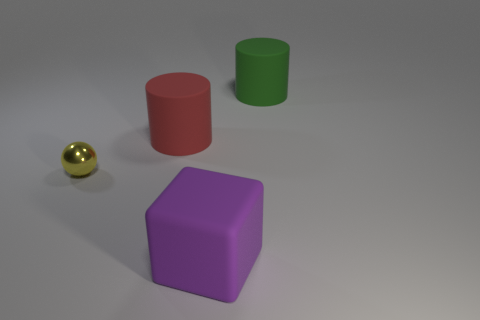Do the red object and the big green thing have the same shape?
Offer a terse response. Yes. What size is the green matte thing that is the same shape as the red rubber thing?
Your response must be concise. Large. Does the thing in front of the metal thing have the same size as the green object?
Offer a terse response. Yes. What size is the object that is both on the left side of the purple rubber cube and behind the small yellow sphere?
Offer a terse response. Large. What number of small objects have the same color as the small sphere?
Provide a short and direct response. 0. Are there an equal number of green things that are left of the purple object and yellow rubber objects?
Offer a terse response. Yes. The tiny ball has what color?
Make the answer very short. Yellow. There is a green cylinder that is made of the same material as the purple block; what is its size?
Your response must be concise. Large. What color is the large cube that is made of the same material as the red object?
Your response must be concise. Purple. Is there a yellow sphere that has the same size as the yellow metallic object?
Make the answer very short. No. 